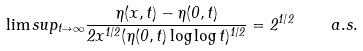<formula> <loc_0><loc_0><loc_500><loc_500>\lim s u p _ { t \to \infty } \frac { \eta ( x , t ) - \eta ( 0 , t ) } { 2 x ^ { 1 / 2 } ( \eta ( 0 , t ) \log \log t ) ^ { 1 / 2 } } = 2 ^ { 1 / 2 } \quad a . s .</formula> 